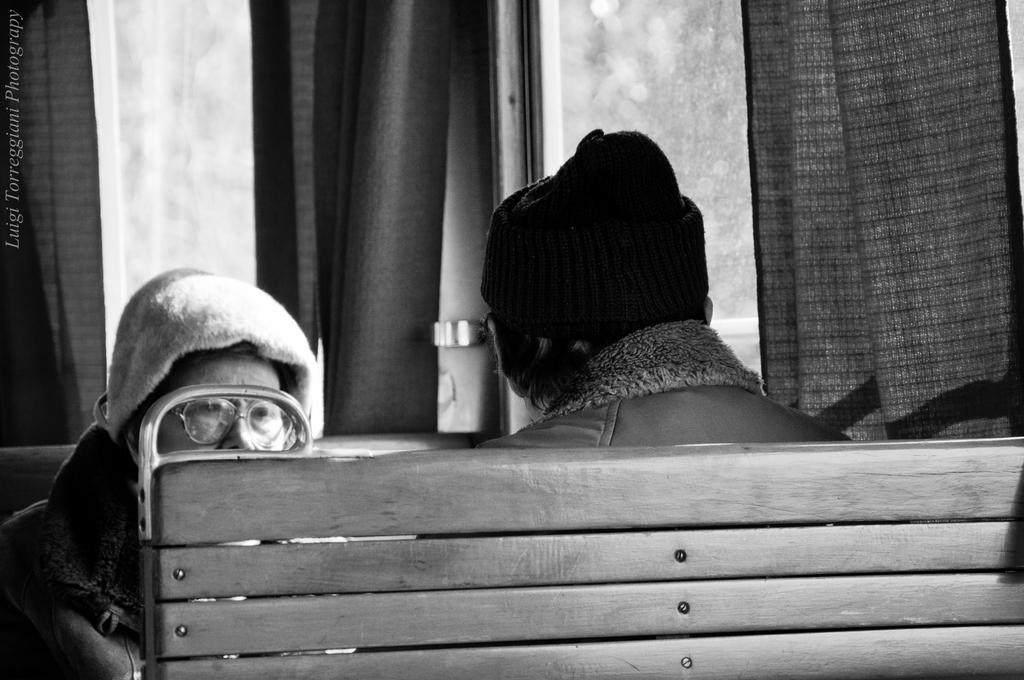How many people are sitting in the image? There are two persons sitting on benches in the image. What can be seen behind the persons? There are glass windows with curtains in the image. What type of fork is being used by the person on the left in the image? There is no fork present in the image; it only shows two persons sitting on benches and glass windows with curtains. 